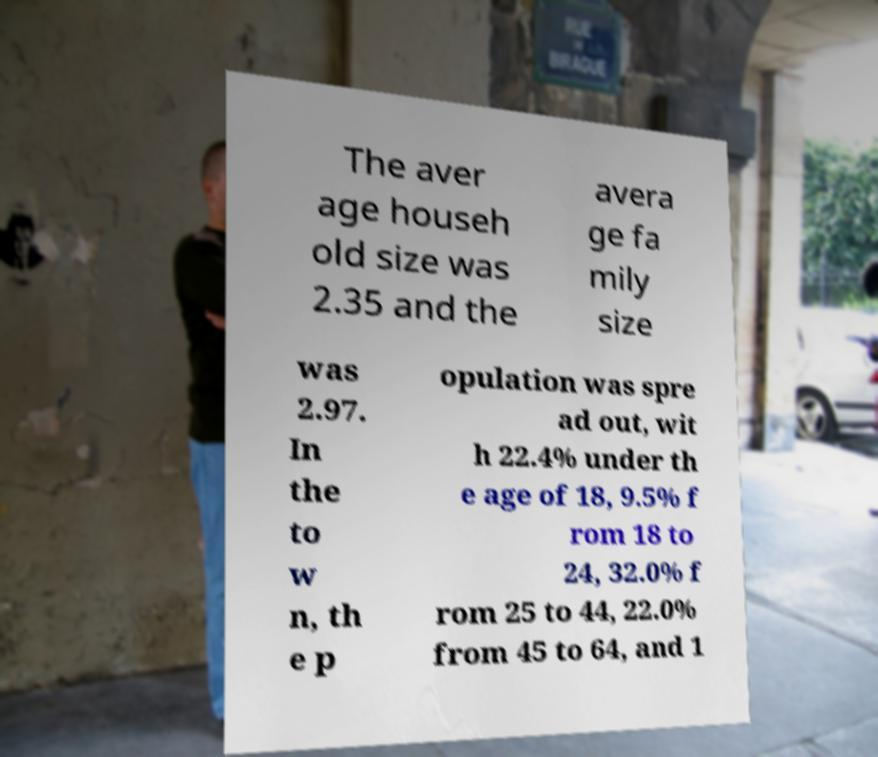Could you assist in decoding the text presented in this image and type it out clearly? The aver age househ old size was 2.35 and the avera ge fa mily size was 2.97. In the to w n, th e p opulation was spre ad out, wit h 22.4% under th e age of 18, 9.5% f rom 18 to 24, 32.0% f rom 25 to 44, 22.0% from 45 to 64, and 1 